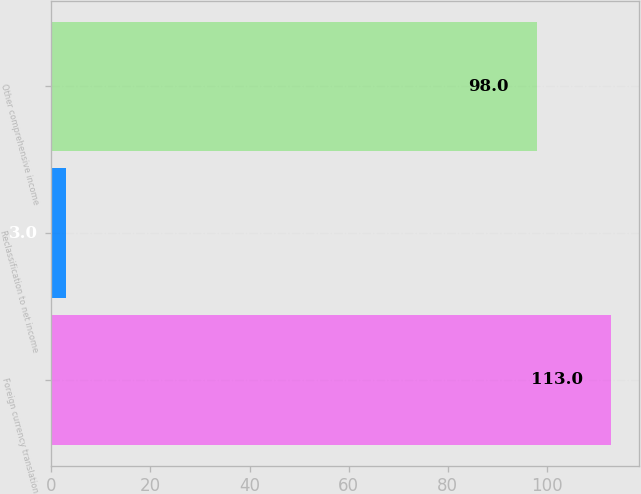Convert chart. <chart><loc_0><loc_0><loc_500><loc_500><bar_chart><fcel>Foreign currency translation<fcel>Reclassification to net income<fcel>Other comprehensive income<nl><fcel>113<fcel>3<fcel>98<nl></chart> 